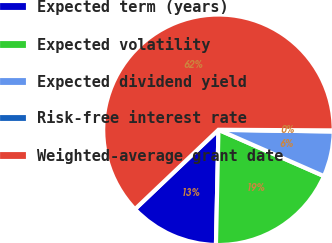Convert chart. <chart><loc_0><loc_0><loc_500><loc_500><pie_chart><fcel>Expected term (years)<fcel>Expected volatility<fcel>Expected dividend yield<fcel>Risk-free interest rate<fcel>Weighted-average grant date<nl><fcel>12.55%<fcel>18.76%<fcel>6.35%<fcel>0.15%<fcel>62.19%<nl></chart> 